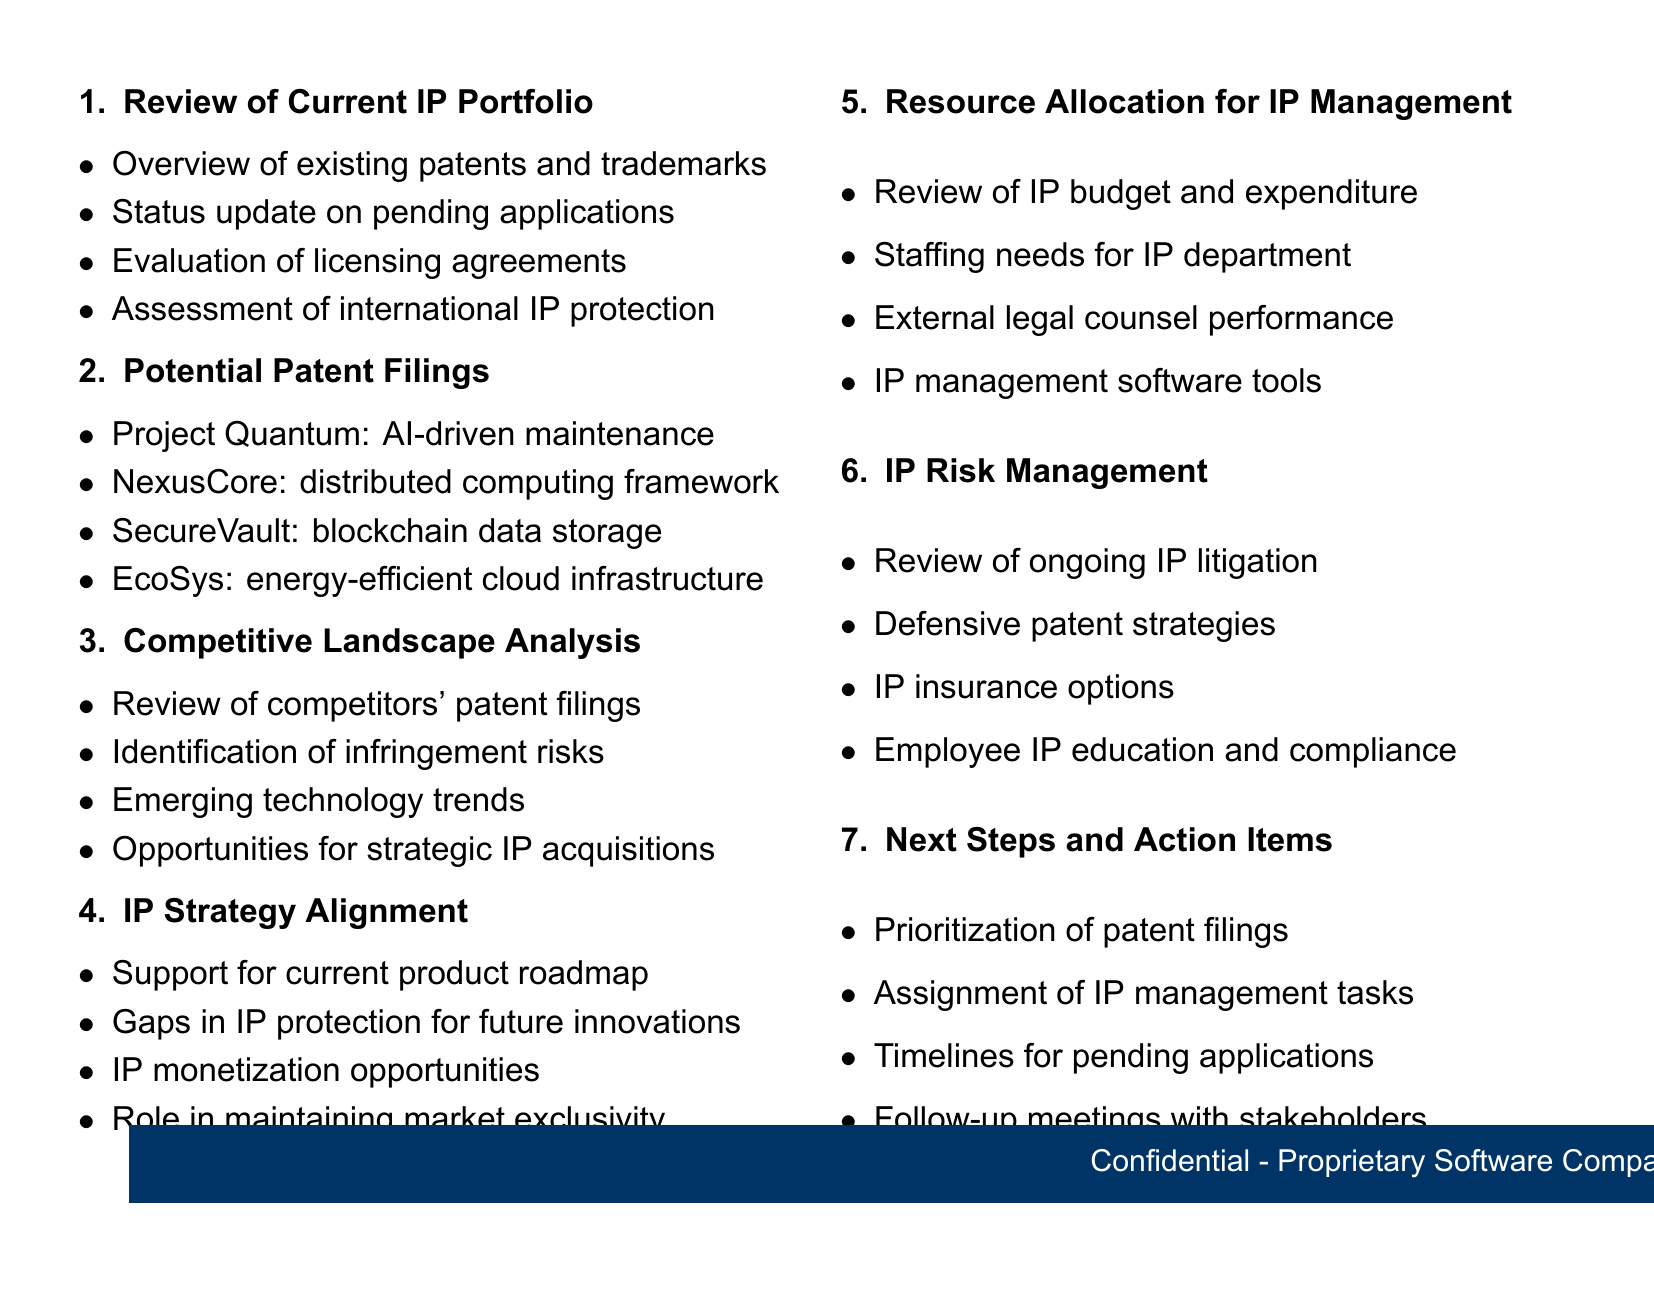What is on the agenda for the IP portfolio review? The agenda includes various topics such as the current IP portfolio review, potential patent filings, competitive landscape analysis, and others.
Answer: Monthly IP Portfolio Review How many items are listed under the potential patent filings? The section lists four exclusive technologies that are being considered for patent filings.
Answer: Four What is the title of the first sub-item under the "Review of Current IP Portfolio"? The first sub-item is an overview of existing patents and trademarks.
Answer: Overview of existing patents and trademarks Who are the external legal counsels evaluated in resource allocation? The document mentions two law firms, Fish & Richardson and Morrison & Foerster.
Answer: Fish & Richardson, Morrison & Foerster What is the focus of Project Quantum discussed in the potential patent filings? Project Quantum focuses on an AI-driven predictive maintenance algorithm.
Answer: AI-driven predictive maintenance algorithm What is the first step listed in the "Next Steps and Action Items"? The first step is prioritization of patent filings for the next quarter.
Answer: Prioritization of patent filings for next quarter What aspect does the IP strategy alignment assess regarding market presence? The assessment evaluates the IP's role in maintaining market exclusivity.
Answer: Maintaining market exclusivity Which competitors' patent filings are under review in the competitive landscape analysis? The document lists IBM, SAP, and Salesforce as competitors whose patent filings will be reviewed.
Answer: IBM, SAP, Salesforce 